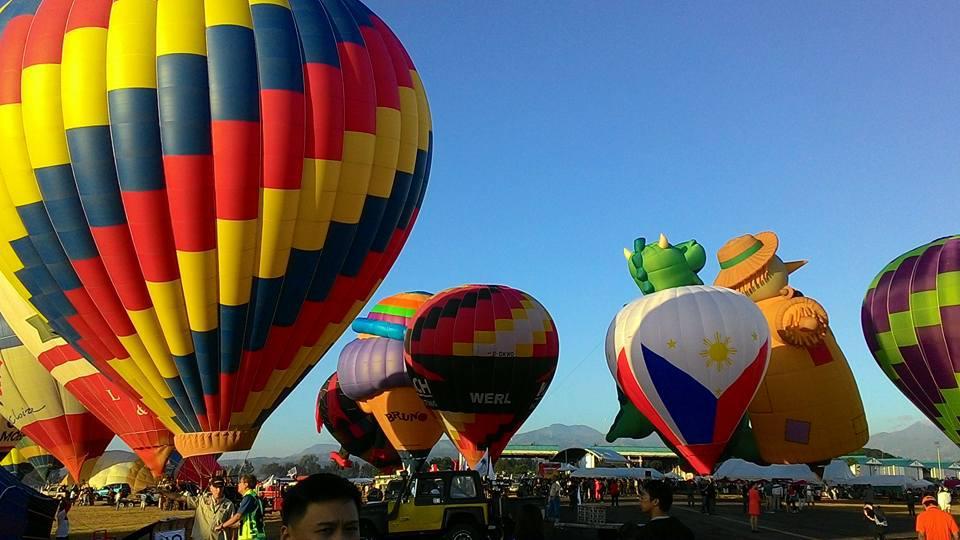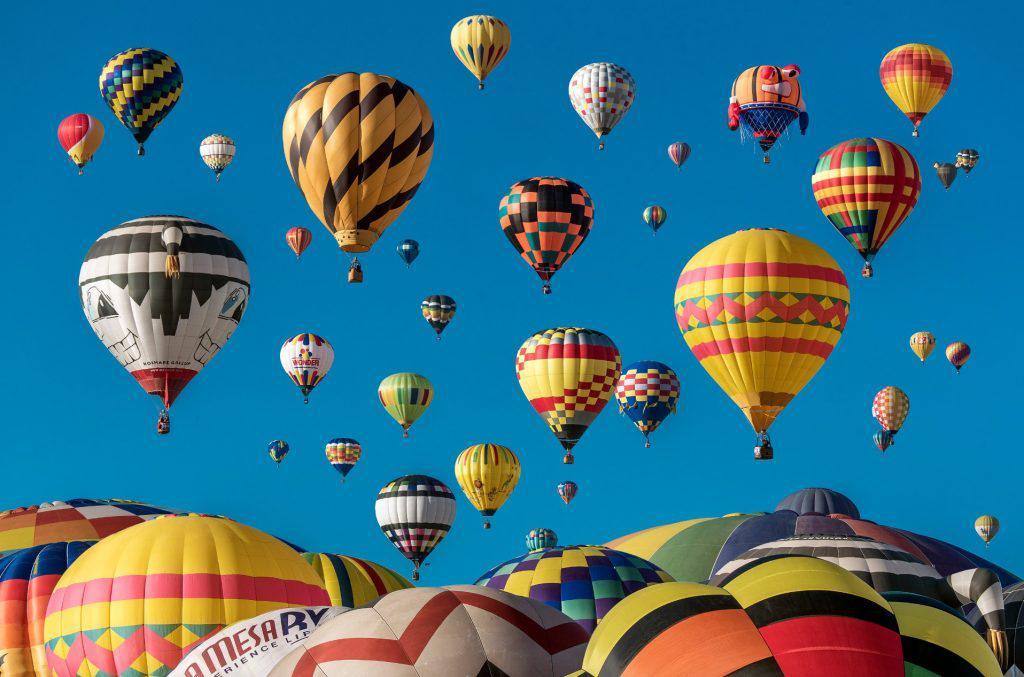The first image is the image on the left, the second image is the image on the right. Analyze the images presented: Is the assertion "there are exactly seven balloons in the image on the right" valid? Answer yes or no. No. The first image is the image on the left, the second image is the image on the right. Considering the images on both sides, is "An image shows just one multi-colored balloon against a cloudless sky." valid? Answer yes or no. No. 